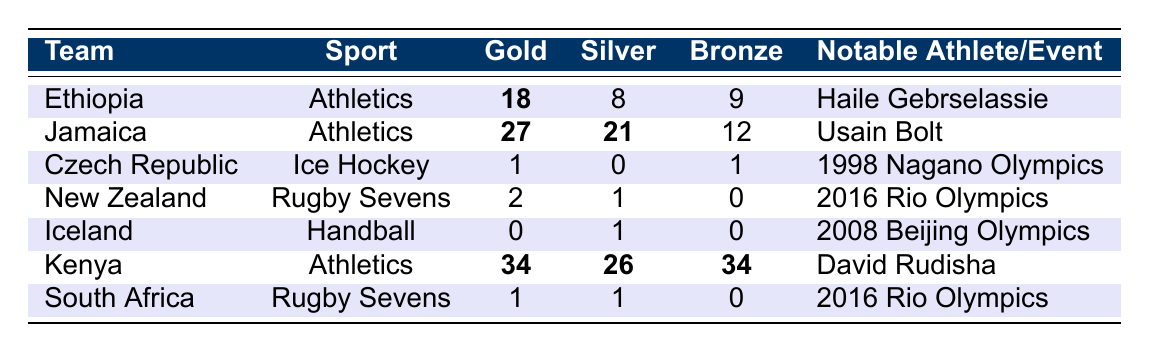What is the total number of gold medals won by Ethiopia and Kenya combined? Ethiopia has 18 gold medals and Kenya has 34 gold medals. Adding these gives 18 + 34 = 52 gold medals in total.
Answer: 52 Which team has the highest silver medal count? Jamaica has 21 silver medals, which is the highest compared to the other teams listed.
Answer: Jamaica Did Iceland win any gold medals? According to the table, Iceland has 0 gold medals, indicating they did not win any.
Answer: No What is the combined total of silver and bronze medals for New Zealand? New Zealand has 1 silver and 0 bronze medals. Adding these yields 1 + 0 = 1 combined medal.
Answer: 1 Which team won the most total medals in athletics? Ethiopia won a total of 35 medals (18 gold + 8 silver + 9 bronze) while Jamaica won 60 medals (27 gold + 21 silver + 12 bronze), making Jamaica the team with the most medals in Athletics.
Answer: Jamaica Is it true that the Czech Republic has won more medals than South Africa? The Czech Republic has 2 total medals (1 gold + 1 bronze) while South Africa has 2 total medals (1 gold + 1 silver), making their total equal, so the statement is false.
Answer: No Calculate the average number of bronze medals won by the teams listed in the table. The total bronze medals from the table are 9 (Ethiopia) + 12 (Jamaica) + 1 (Czech Republic) + 0 (New Zealand) + 0 (Iceland) + 34 (Kenya) + 0 (South Africa) = 56. There are 7 teams, so the average is 56 / 7 = 8.
Answer: 8 Which sport does Kenya excel in based on their medal count? The medal count indicates Kenya excels in Athletics, as they have the highest total of gold, silver, and bronze medals in that sport.
Answer: Athletics What percentage of Jamaica's total medals are gold? Jamaica has a total of 60 medals (27 gold + 21 silver + 12 bronze). The percentage of gold medals is (27/60) * 100 = 45%.
Answer: 45% 